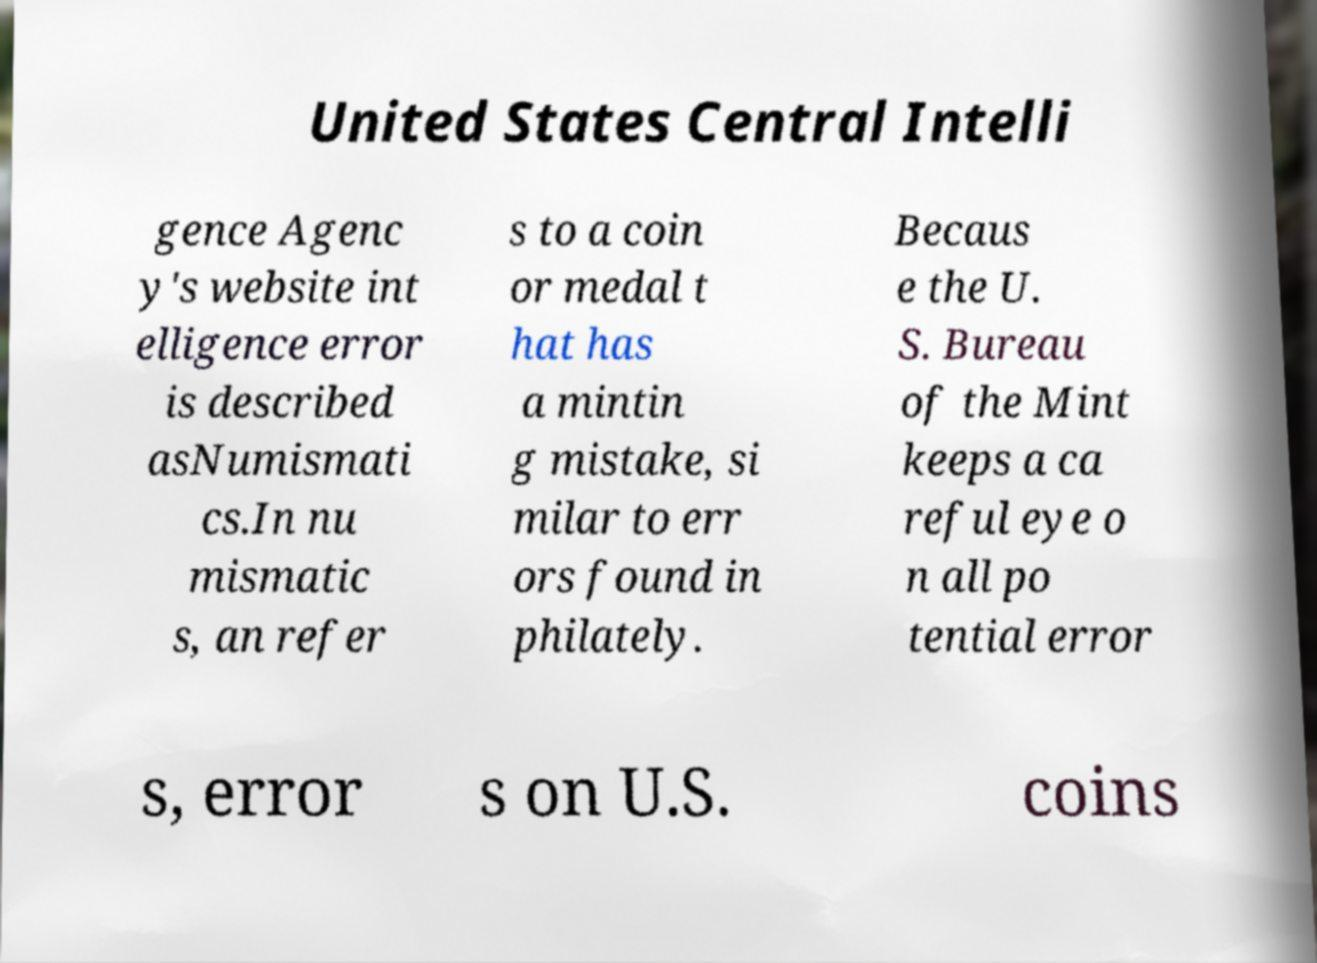Can you read and provide the text displayed in the image?This photo seems to have some interesting text. Can you extract and type it out for me? United States Central Intelli gence Agenc y's website int elligence error is described asNumismati cs.In nu mismatic s, an refer s to a coin or medal t hat has a mintin g mistake, si milar to err ors found in philately. Becaus e the U. S. Bureau of the Mint keeps a ca reful eye o n all po tential error s, error s on U.S. coins 